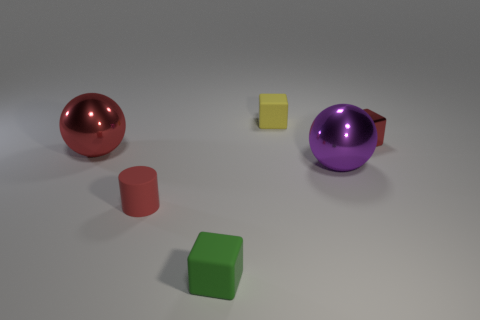Subtract all green cubes. How many cubes are left? 2 Subtract 0 cyan cylinders. How many objects are left? 6 Subtract all balls. How many objects are left? 4 Subtract 2 spheres. How many spheres are left? 0 Subtract all gray spheres. Subtract all blue cylinders. How many spheres are left? 2 Subtract all gray cubes. How many blue cylinders are left? 0 Subtract all shiny cubes. Subtract all metal blocks. How many objects are left? 4 Add 2 matte objects. How many matte objects are left? 5 Add 5 red metallic spheres. How many red metallic spheres exist? 6 Add 2 gray metallic spheres. How many objects exist? 8 